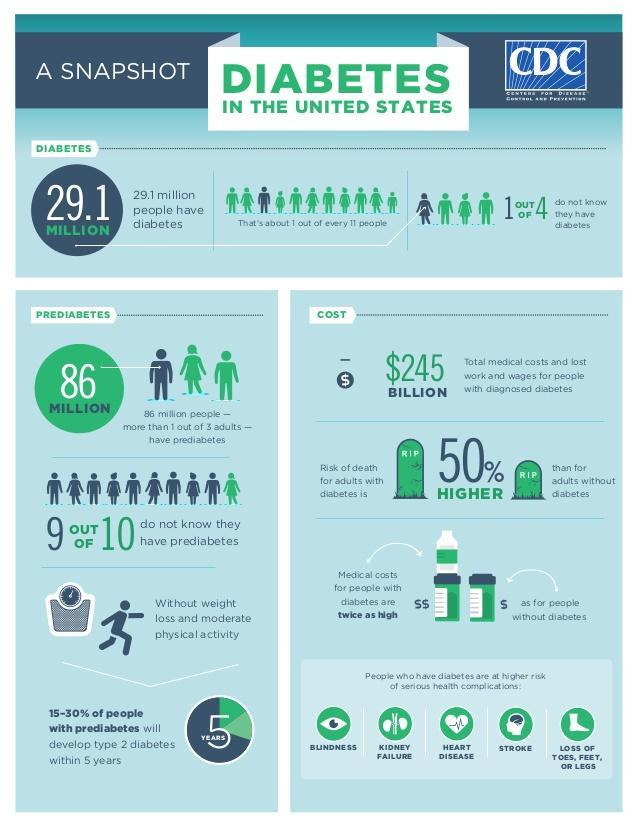what percentage people do not know they have prediabetes
Answer the question with a short phrase. 90 what happens without weight loss and moderate physical activity 15-30% of people with prediabetes will develop type 2 diabetes within 5 years what is the health risk to eyes due to diabetes blindness what percentage people do not know they have diabetes 25 what is the health risk to brains due to diabetes stroke 